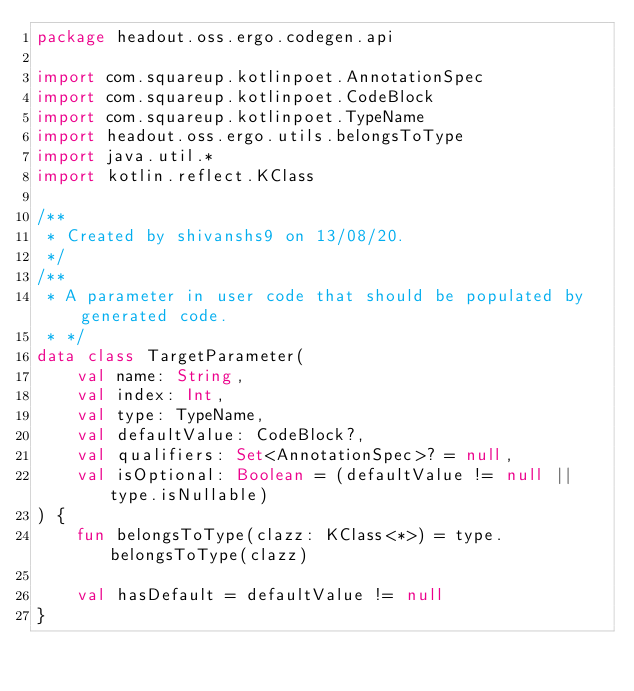Convert code to text. <code><loc_0><loc_0><loc_500><loc_500><_Kotlin_>package headout.oss.ergo.codegen.api

import com.squareup.kotlinpoet.AnnotationSpec
import com.squareup.kotlinpoet.CodeBlock
import com.squareup.kotlinpoet.TypeName
import headout.oss.ergo.utils.belongsToType
import java.util.*
import kotlin.reflect.KClass

/**
 * Created by shivanshs9 on 13/08/20.
 */
/**
 * A parameter in user code that should be populated by generated code.
 * */
data class TargetParameter(
    val name: String,
    val index: Int,
    val type: TypeName,
    val defaultValue: CodeBlock?,
    val qualifiers: Set<AnnotationSpec>? = null,
    val isOptional: Boolean = (defaultValue != null || type.isNullable)
) {
    fun belongsToType(clazz: KClass<*>) = type.belongsToType(clazz)

    val hasDefault = defaultValue != null
}</code> 